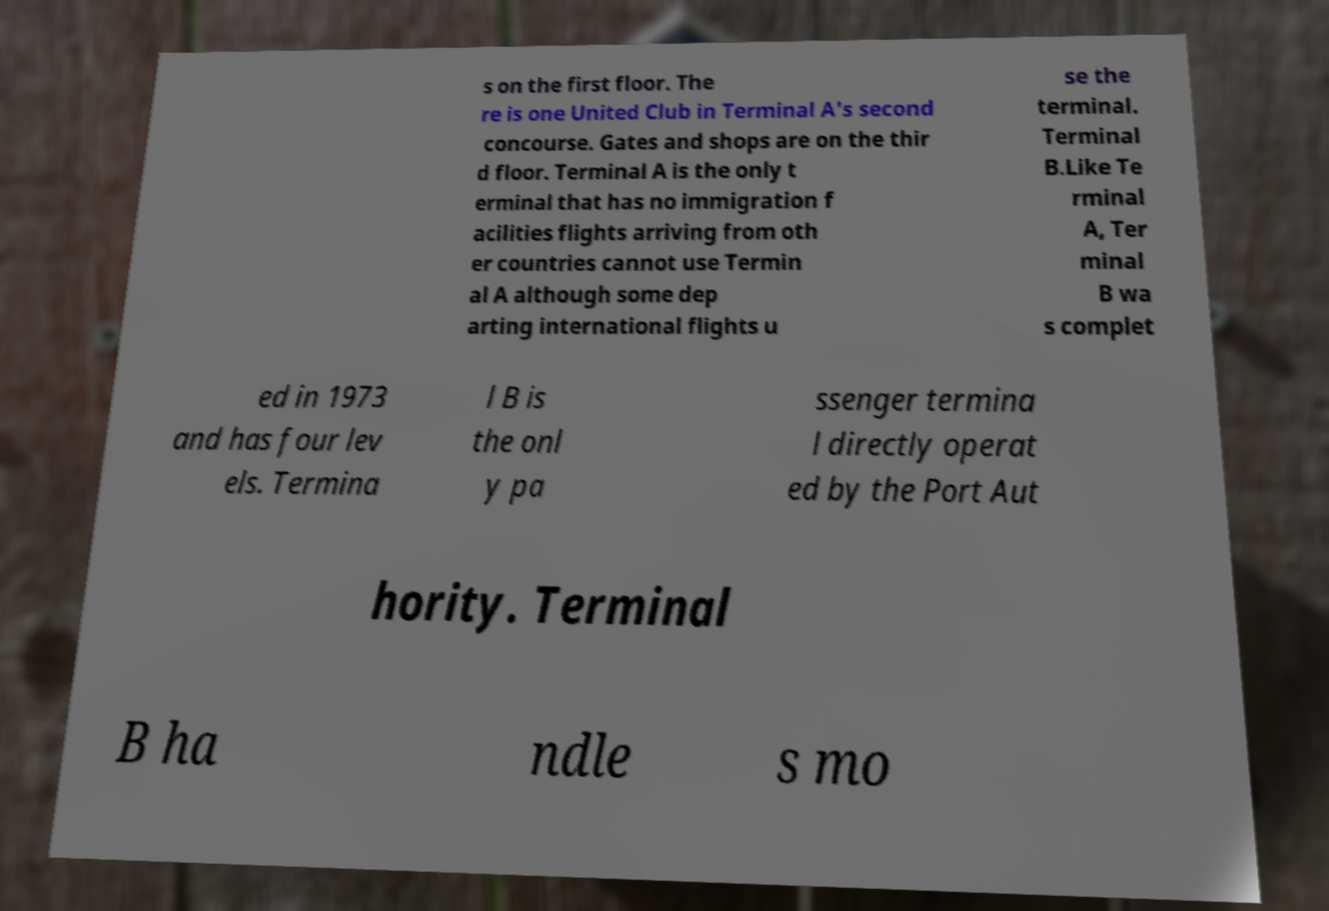Please identify and transcribe the text found in this image. s on the first floor. The re is one United Club in Terminal A's second concourse. Gates and shops are on the thir d floor. Terminal A is the only t erminal that has no immigration f acilities flights arriving from oth er countries cannot use Termin al A although some dep arting international flights u se the terminal. Terminal B.Like Te rminal A, Ter minal B wa s complet ed in 1973 and has four lev els. Termina l B is the onl y pa ssenger termina l directly operat ed by the Port Aut hority. Terminal B ha ndle s mo 